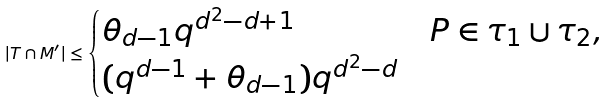Convert formula to latex. <formula><loc_0><loc_0><loc_500><loc_500>| T \cap M ^ { \prime } | \leq \begin{cases} \theta _ { d - 1 } q ^ { d ^ { 2 } - d + 1 } & P \in \tau _ { 1 } \cup \tau _ { 2 } , \\ ( q ^ { d - 1 } + \theta _ { d - 1 } ) q ^ { d ^ { 2 } - d } & \end{cases}</formula> 